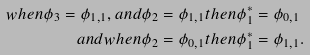Convert formula to latex. <formula><loc_0><loc_0><loc_500><loc_500>w h e n \phi _ { 3 } = \phi _ { 1 , 1 } , a n d & \phi _ { 2 } = \phi _ { 1 , 1 } t h e n \phi ^ { * } _ { 1 } = \phi _ { 0 , 1 } \\ a n d w h e n & \phi _ { 2 } = \phi _ { 0 , 1 } t h e n \phi ^ { * } _ { 1 } = \phi _ { 1 , 1 } .</formula> 